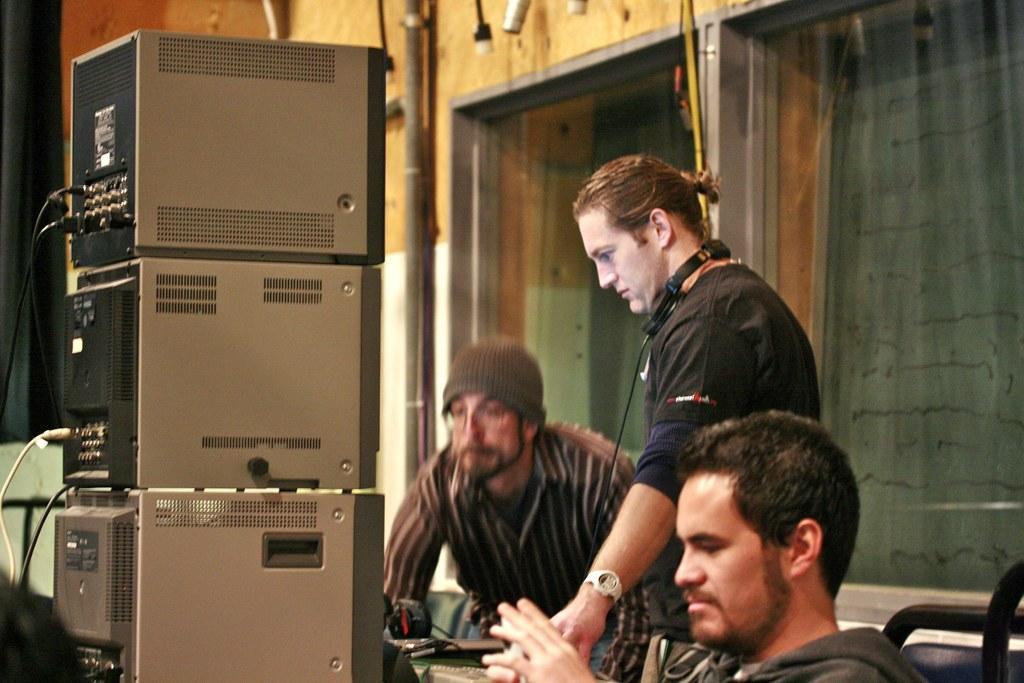Describe this image in one or two sentences. In this image in front there is a person sitting on the chair. In front of him there are few objects. Beside him there are few other people. In the background of the image there are glass doors through which we can see the curtains. There is a wall. On the left side of the image there is a black color curtain. 